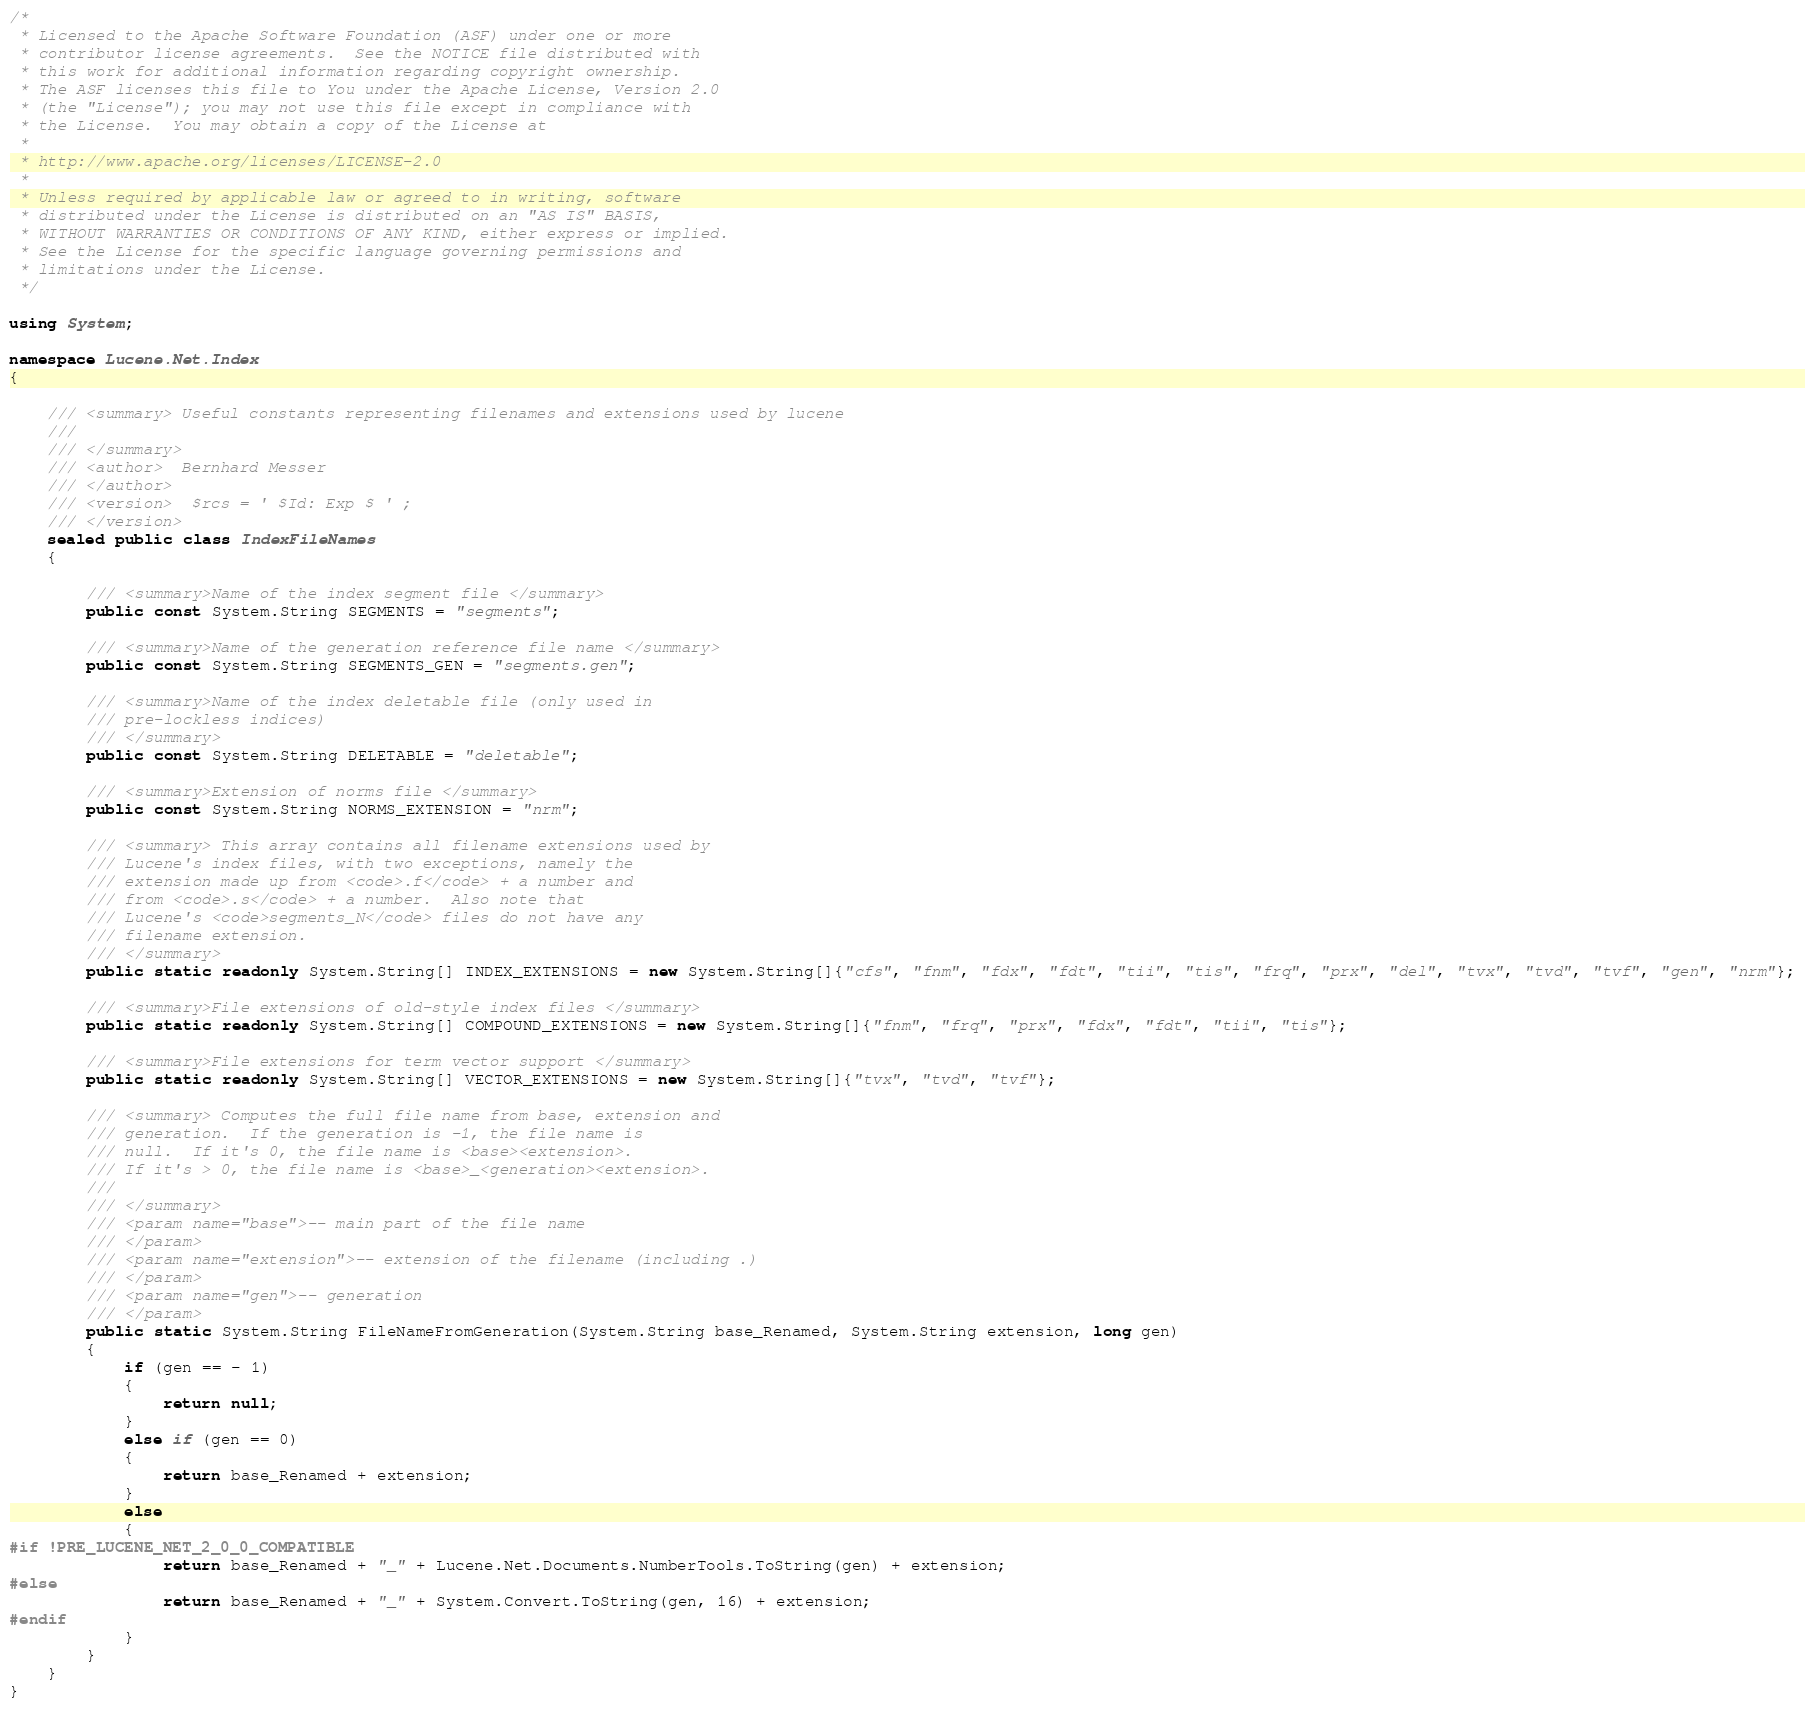Convert code to text. <code><loc_0><loc_0><loc_500><loc_500><_C#_>/*
 * Licensed to the Apache Software Foundation (ASF) under one or more
 * contributor license agreements.  See the NOTICE file distributed with
 * this work for additional information regarding copyright ownership.
 * The ASF licenses this file to You under the Apache License, Version 2.0
 * (the "License"); you may not use this file except in compliance with
 * the License.  You may obtain a copy of the License at
 * 
 * http://www.apache.org/licenses/LICENSE-2.0
 * 
 * Unless required by applicable law or agreed to in writing, software
 * distributed under the License is distributed on an "AS IS" BASIS,
 * WITHOUT WARRANTIES OR CONDITIONS OF ANY KIND, either express or implied.
 * See the License for the specific language governing permissions and
 * limitations under the License.
 */

using System;

namespace Lucene.Net.Index
{
	
	/// <summary> Useful constants representing filenames and extensions used by lucene
	/// 
	/// </summary>
	/// <author>  Bernhard Messer
	/// </author>
	/// <version>  $rcs = ' $Id: Exp $ ' ;
	/// </version>
	sealed public class IndexFileNames
	{
		
		/// <summary>Name of the index segment file </summary>
		public const System.String SEGMENTS = "segments";
		
		/// <summary>Name of the generation reference file name </summary>
		public const System.String SEGMENTS_GEN = "segments.gen";
		
		/// <summary>Name of the index deletable file (only used in
		/// pre-lockless indices) 
		/// </summary>
		public const System.String DELETABLE = "deletable";
		
		/// <summary>Extension of norms file </summary>
		public const System.String NORMS_EXTENSION = "nrm";
		
		/// <summary> This array contains all filename extensions used by
		/// Lucene's index files, with two exceptions, namely the
		/// extension made up from <code>.f</code> + a number and
		/// from <code>.s</code> + a number.  Also note that
		/// Lucene's <code>segments_N</code> files do not have any
		/// filename extension.
		/// </summary>
		public static readonly System.String[] INDEX_EXTENSIONS = new System.String[]{"cfs", "fnm", "fdx", "fdt", "tii", "tis", "frq", "prx", "del", "tvx", "tvd", "tvf", "gen", "nrm"};
		
		/// <summary>File extensions of old-style index files </summary>
		public static readonly System.String[] COMPOUND_EXTENSIONS = new System.String[]{"fnm", "frq", "prx", "fdx", "fdt", "tii", "tis"};
		
		/// <summary>File extensions for term vector support </summary>
		public static readonly System.String[] VECTOR_EXTENSIONS = new System.String[]{"tvx", "tvd", "tvf"};
		
		/// <summary> Computes the full file name from base, extension and
		/// generation.  If the generation is -1, the file name is
		/// null.  If it's 0, the file name is <base><extension>.
		/// If it's > 0, the file name is <base>_<generation><extension>.
		/// 
		/// </summary>
		/// <param name="base">-- main part of the file name
		/// </param>
		/// <param name="extension">-- extension of the filename (including .)
		/// </param>
		/// <param name="gen">-- generation
		/// </param>
		public static System.String FileNameFromGeneration(System.String base_Renamed, System.String extension, long gen)
		{
			if (gen == - 1)
			{
				return null;
			}
			else if (gen == 0)
			{
				return base_Renamed + extension;
			}
			else
			{
#if !PRE_LUCENE_NET_2_0_0_COMPATIBLE
                return base_Renamed + "_" + Lucene.Net.Documents.NumberTools.ToString(gen) + extension;
#else
				return base_Renamed + "_" + System.Convert.ToString(gen, 16) + extension;
#endif
			}
		}
	}
}</code> 